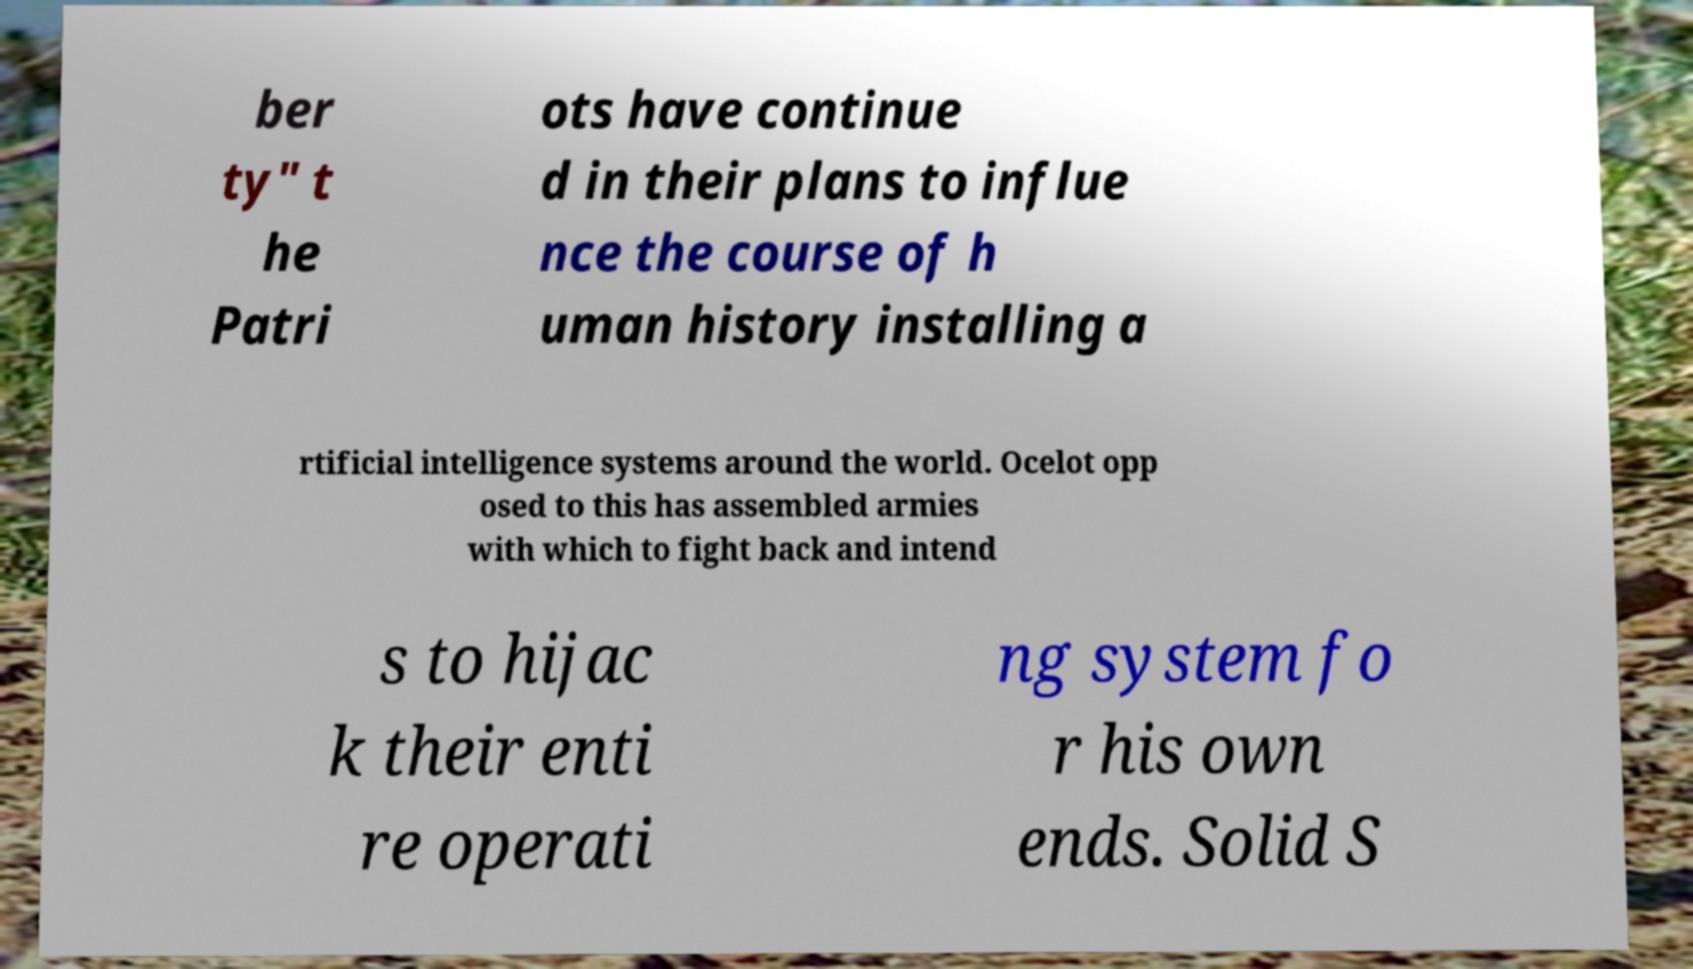Please read and relay the text visible in this image. What does it say? ber ty" t he Patri ots have continue d in their plans to influe nce the course of h uman history installing a rtificial intelligence systems around the world. Ocelot opp osed to this has assembled armies with which to fight back and intend s to hijac k their enti re operati ng system fo r his own ends. Solid S 